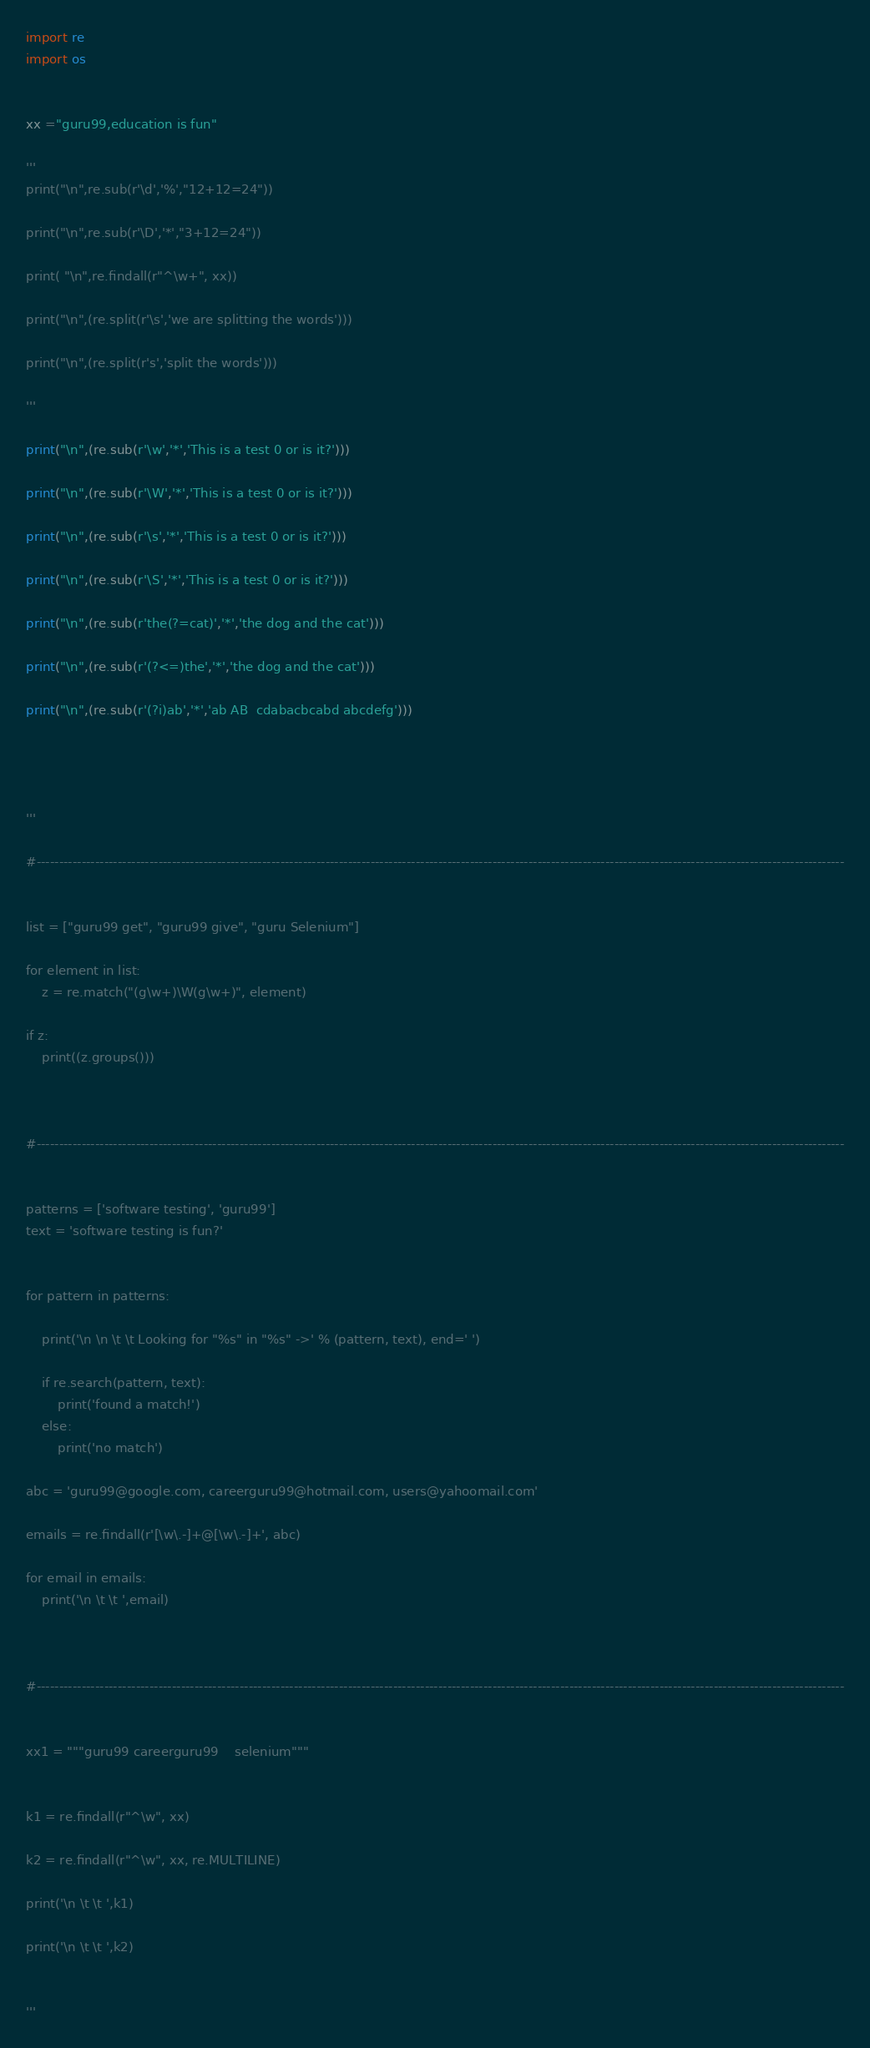<code> <loc_0><loc_0><loc_500><loc_500><_Python_>import re
import os


xx ="guru99,education is fun"

'''
print("\n",re.sub(r'\d','%',"12+12=24"))

print("\n",re.sub(r'\D','*',"3+12=24"))

print( "\n",re.findall(r"^\w+", xx))

print("\n",(re.split(r'\s','we are splitting the words')))

print("\n",(re.split(r's','split the words')))

'''

print("\n",(re.sub(r'\w','*','This is a test 0 or is it?')))

print("\n",(re.sub(r'\W','*','This is a test 0 or is it?')))

print("\n",(re.sub(r'\s','*','This is a test 0 or is it?')))

print("\n",(re.sub(r'\S','*','This is a test 0 or is it?')))

print("\n",(re.sub(r'the(?=cat)','*','the dog and the cat')))

print("\n",(re.sub(r'(?<=)the','*','the dog and the cat')))

print("\n",(re.sub(r'(?i)ab','*','ab AB  cdabacbcabd abcdefg')))




'''

#-----------------------------------------------------------------------------------------------------------------------------------------------------------------------------------


list = ["guru99 get", "guru99 give", "guru Selenium"]

for element in list:
    z = re.match("(g\w+)\W(g\w+)", element)

if z:
    print((z.groups()))
    


#-----------------------------------------------------------------------------------------------------------------------------------------------------------------------------------

    
patterns = ['software testing', 'guru99']
text = 'software testing is fun?'


for pattern in patterns:

    print('\n \n \t \t Looking for "%s" in "%s" ->' % (pattern, text), end=' ')

    if re.search(pattern, text):
        print('found a match!')
    else:
        print('no match')

abc = 'guru99@google.com, careerguru99@hotmail.com, users@yahoomail.com'

emails = re.findall(r'[\w\.-]+@[\w\.-]+', abc)

for email in emails:
    print('\n \t \t ',email)



#-----------------------------------------------------------------------------------------------------------------------------------------------------------------------------------


xx1 = """guru99 careerguru99	selenium"""


k1 = re.findall(r"^\w", xx)

k2 = re.findall(r"^\w", xx, re.MULTILINE)

print('\n \t \t ',k1)

print('\n \t \t ',k2)


'''
</code> 